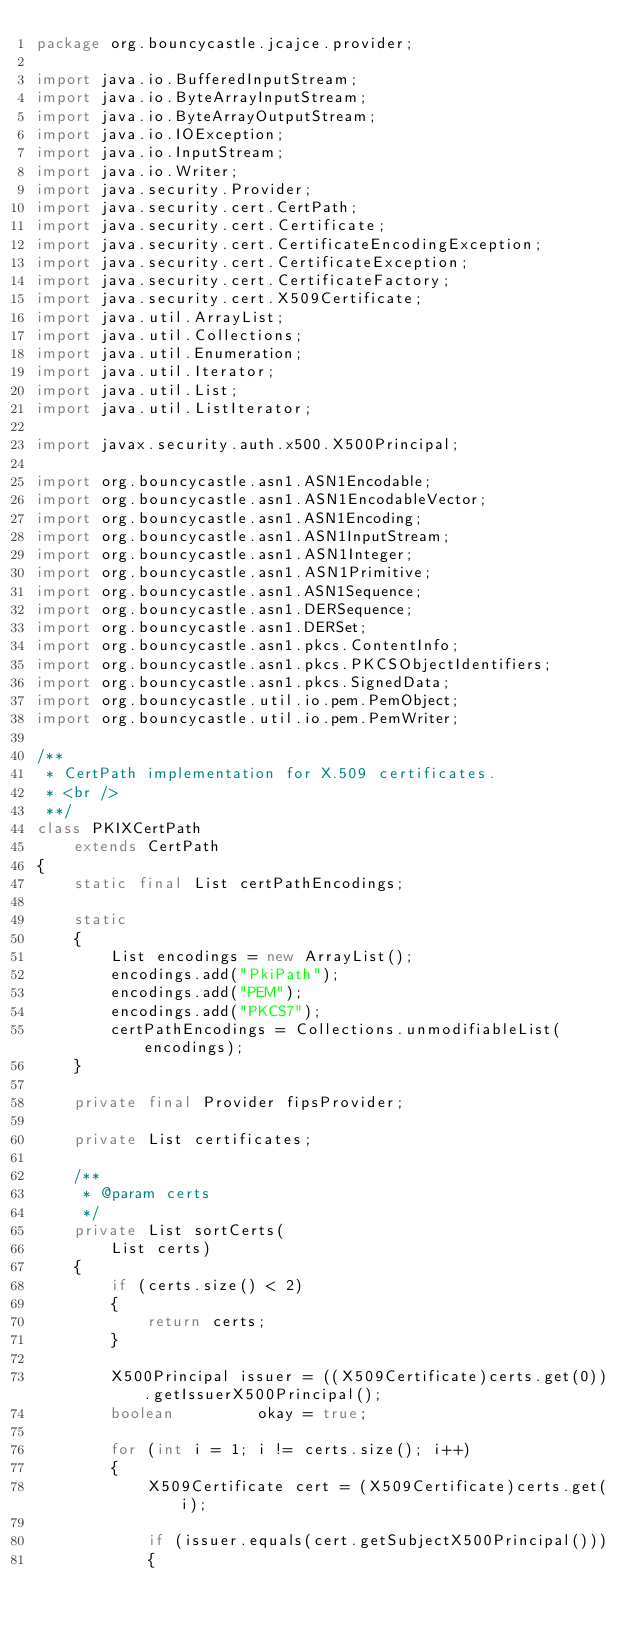<code> <loc_0><loc_0><loc_500><loc_500><_Java_>package org.bouncycastle.jcajce.provider;

import java.io.BufferedInputStream;
import java.io.ByteArrayInputStream;
import java.io.ByteArrayOutputStream;
import java.io.IOException;
import java.io.InputStream;
import java.io.Writer;
import java.security.Provider;
import java.security.cert.CertPath;
import java.security.cert.Certificate;
import java.security.cert.CertificateEncodingException;
import java.security.cert.CertificateException;
import java.security.cert.CertificateFactory;
import java.security.cert.X509Certificate;
import java.util.ArrayList;
import java.util.Collections;
import java.util.Enumeration;
import java.util.Iterator;
import java.util.List;
import java.util.ListIterator;

import javax.security.auth.x500.X500Principal;

import org.bouncycastle.asn1.ASN1Encodable;
import org.bouncycastle.asn1.ASN1EncodableVector;
import org.bouncycastle.asn1.ASN1Encoding;
import org.bouncycastle.asn1.ASN1InputStream;
import org.bouncycastle.asn1.ASN1Integer;
import org.bouncycastle.asn1.ASN1Primitive;
import org.bouncycastle.asn1.ASN1Sequence;
import org.bouncycastle.asn1.DERSequence;
import org.bouncycastle.asn1.DERSet;
import org.bouncycastle.asn1.pkcs.ContentInfo;
import org.bouncycastle.asn1.pkcs.PKCSObjectIdentifiers;
import org.bouncycastle.asn1.pkcs.SignedData;
import org.bouncycastle.util.io.pem.PemObject;
import org.bouncycastle.util.io.pem.PemWriter;

/**
 * CertPath implementation for X.509 certificates.
 * <br />
 **/
class PKIXCertPath
    extends CertPath
{
    static final List certPathEncodings;

    static
    {
        List encodings = new ArrayList();
        encodings.add("PkiPath");
        encodings.add("PEM");
        encodings.add("PKCS7");
        certPathEncodings = Collections.unmodifiableList(encodings);
    }

    private final Provider fipsProvider;

    private List certificates;

    /**
     * @param certs
     */
    private List sortCerts(
        List certs)
    {
        if (certs.size() < 2)
        {
            return certs;
        }
        
        X500Principal issuer = ((X509Certificate)certs.get(0)).getIssuerX500Principal();
        boolean         okay = true;
        
        for (int i = 1; i != certs.size(); i++) 
        {
            X509Certificate cert = (X509Certificate)certs.get(i);
            
            if (issuer.equals(cert.getSubjectX500Principal()))
            {</code> 